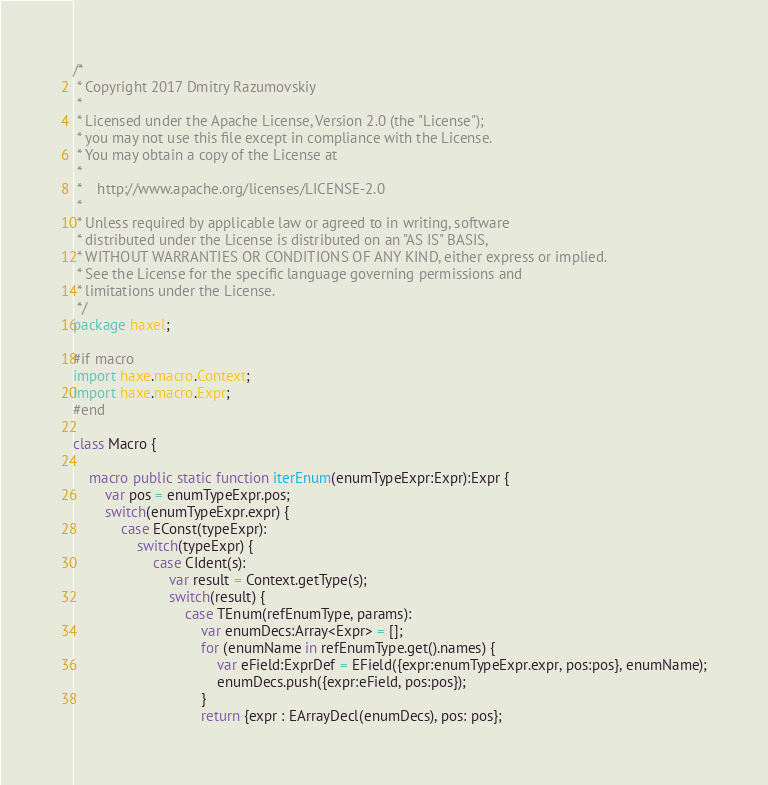Convert code to text. <code><loc_0><loc_0><loc_500><loc_500><_Haxe_>/*
 * Copyright 2017 Dmitry Razumovskiy
 *
 * Licensed under the Apache License, Version 2.0 (the "License");
 * you may not use this file except in compliance with the License.
 * You may obtain a copy of the License at
 *
 *    http://www.apache.org/licenses/LICENSE-2.0
 *
 * Unless required by applicable law or agreed to in writing, software
 * distributed under the License is distributed on an "AS IS" BASIS,
 * WITHOUT WARRANTIES OR CONDITIONS OF ANY KIND, either express or implied.
 * See the License for the specific language governing permissions and
 * limitations under the License.
 */
package haxel;

#if macro
import haxe.macro.Context;
import haxe.macro.Expr;
#end

class Macro {

    macro public static function iterEnum(enumTypeExpr:Expr):Expr {
        var pos = enumTypeExpr.pos;
        switch(enumTypeExpr.expr) {
            case EConst(typeExpr):
                switch(typeExpr) {
                    case CIdent(s):
                        var result = Context.getType(s);
                        switch(result) {
                            case TEnum(refEnumType, params):
                                var enumDecs:Array<Expr> = [];
                                for (enumName in refEnumType.get().names) {
                                    var eField:ExprDef = EField({expr:enumTypeExpr.expr, pos:pos}, enumName);
                                    enumDecs.push({expr:eField, pos:pos});
                                }
                                return {expr : EArrayDecl(enumDecs), pos: pos};</code> 